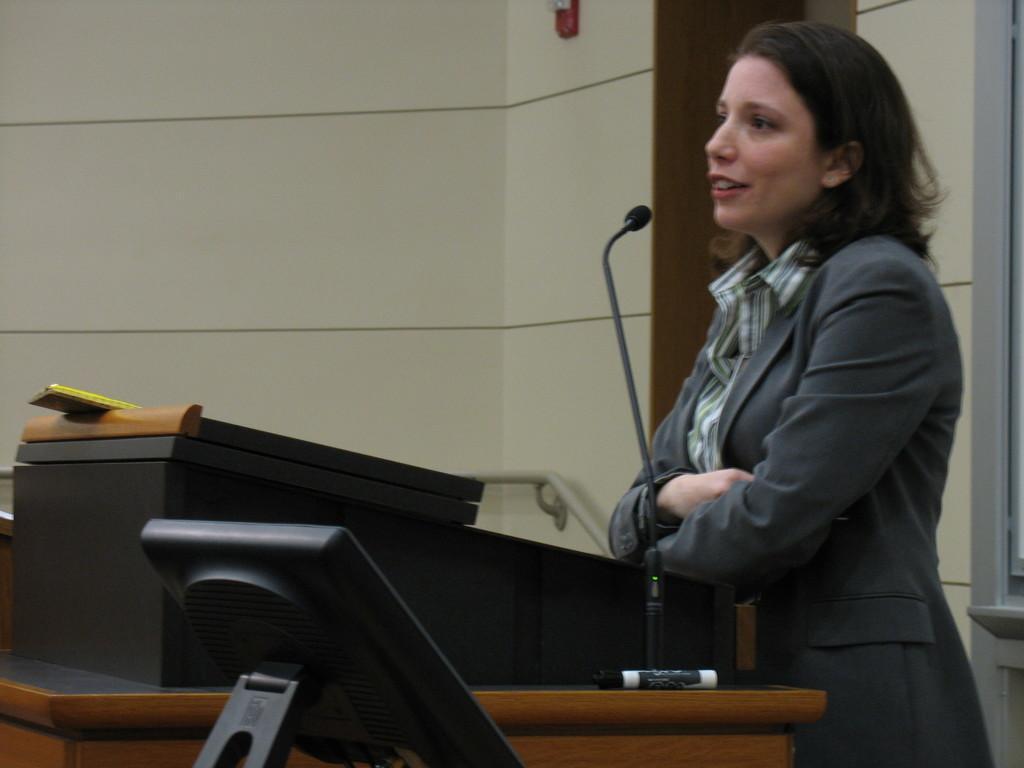Describe this image in one or two sentences. in this image i can see a person on the right side wearing a suit. there is a microphone in front of her. behind her there is a wall. 